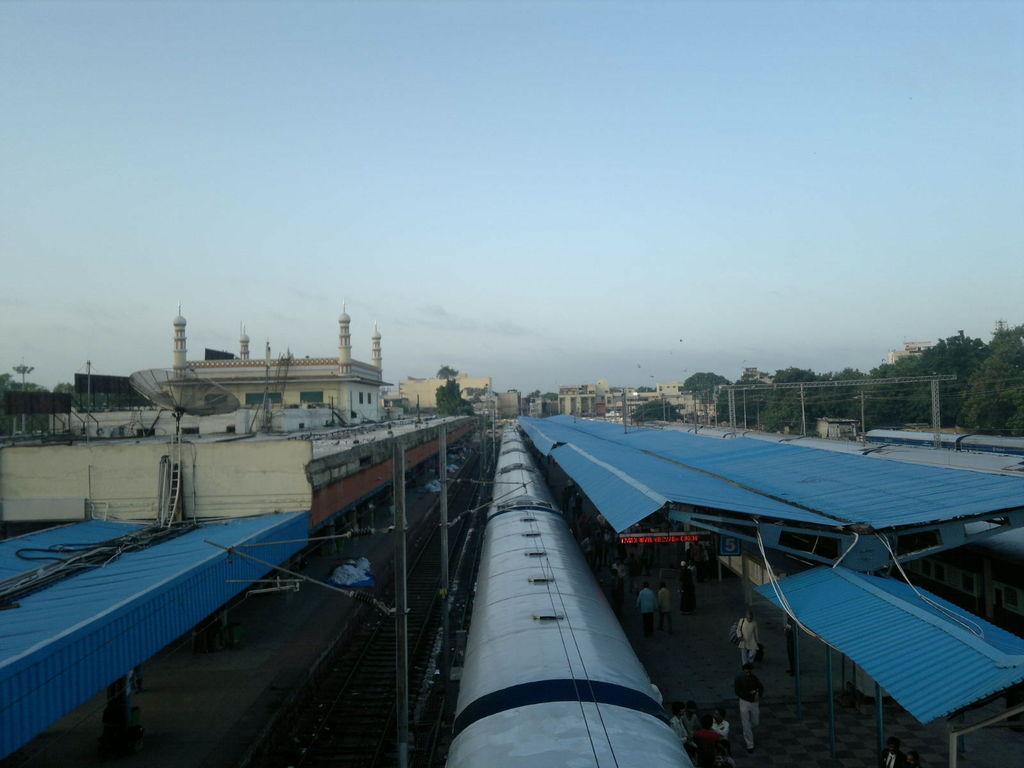Can you describe this image briefly? In this picture we can see trains, beside these trains we can see platforms, people and a railway track and in the background we can see buildings, trees, poles and the sky. 